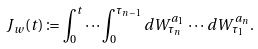Convert formula to latex. <formula><loc_0><loc_0><loc_500><loc_500>J _ { w } ( t ) \coloneqq \int _ { 0 } ^ { t } \cdots \int _ { 0 } ^ { \tau _ { n - 1 } } d W ^ { a _ { 1 } } _ { \tau _ { n } } \, \cdots \, d W ^ { a _ { n } } _ { \tau _ { 1 } } .</formula> 